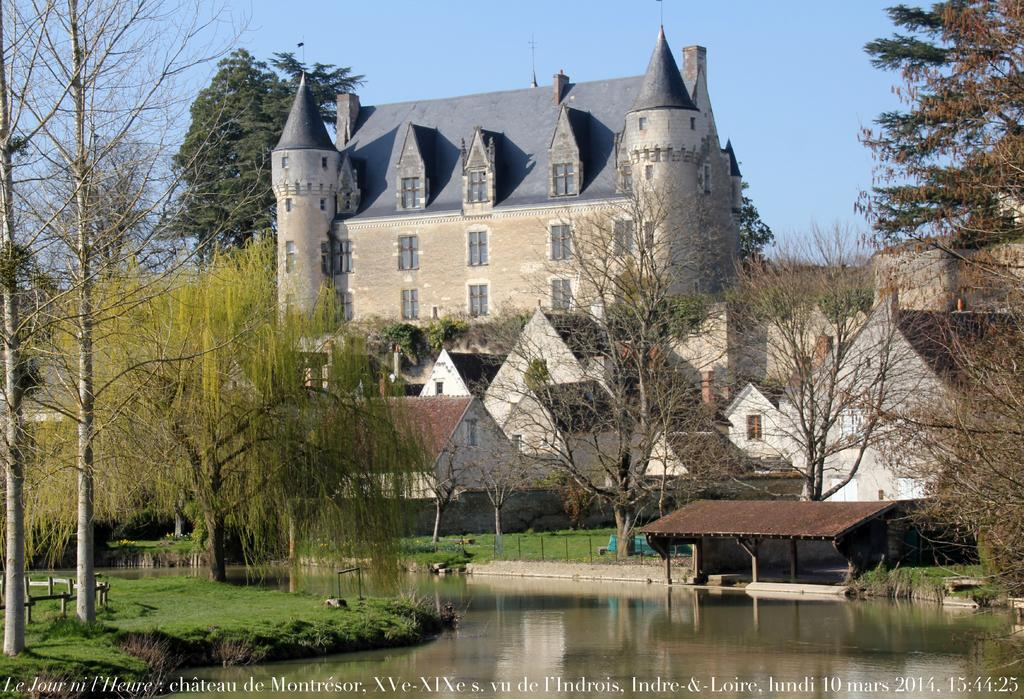What type of structures can be seen in the image? There are roofs of houses in the image. What type of vegetation is present in the image? There are trees and grass in the image. What type of architectural feature can be seen in the image? Fencing rods are visible in the image. What is visible at the top of the image? The sky is visible at the top of the image. What is visible at the bottom of the image? There is water visible at the bottom of the image. Is there any text present in the image? Yes, there is text in the image. What type of dinner is being served in the image? There is no dinner present in the image; it features roofs of houses, trees, grass, fencing rods, the sky, water, and text. What type of tank can be seen in the image? There is no tank present in the image. 